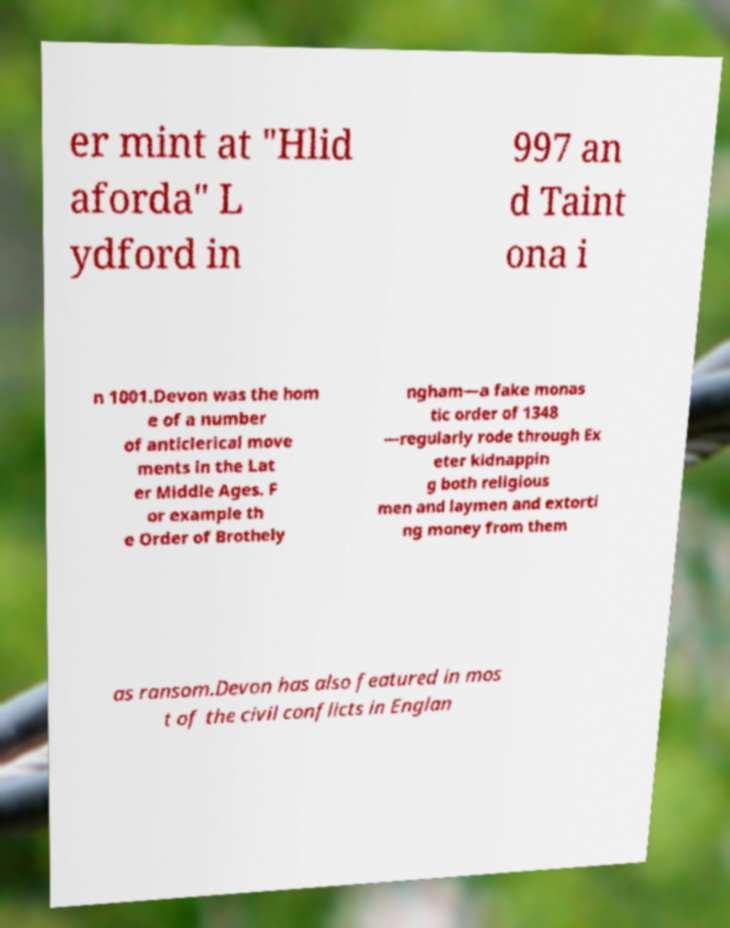Please read and relay the text visible in this image. What does it say? er mint at "Hlid aforda" L ydford in 997 an d Taint ona i n 1001.Devon was the hom e of a number of anticlerical move ments in the Lat er Middle Ages. F or example th e Order of Brothely ngham—a fake monas tic order of 1348 —regularly rode through Ex eter kidnappin g both religious men and laymen and extorti ng money from them as ransom.Devon has also featured in mos t of the civil conflicts in Englan 